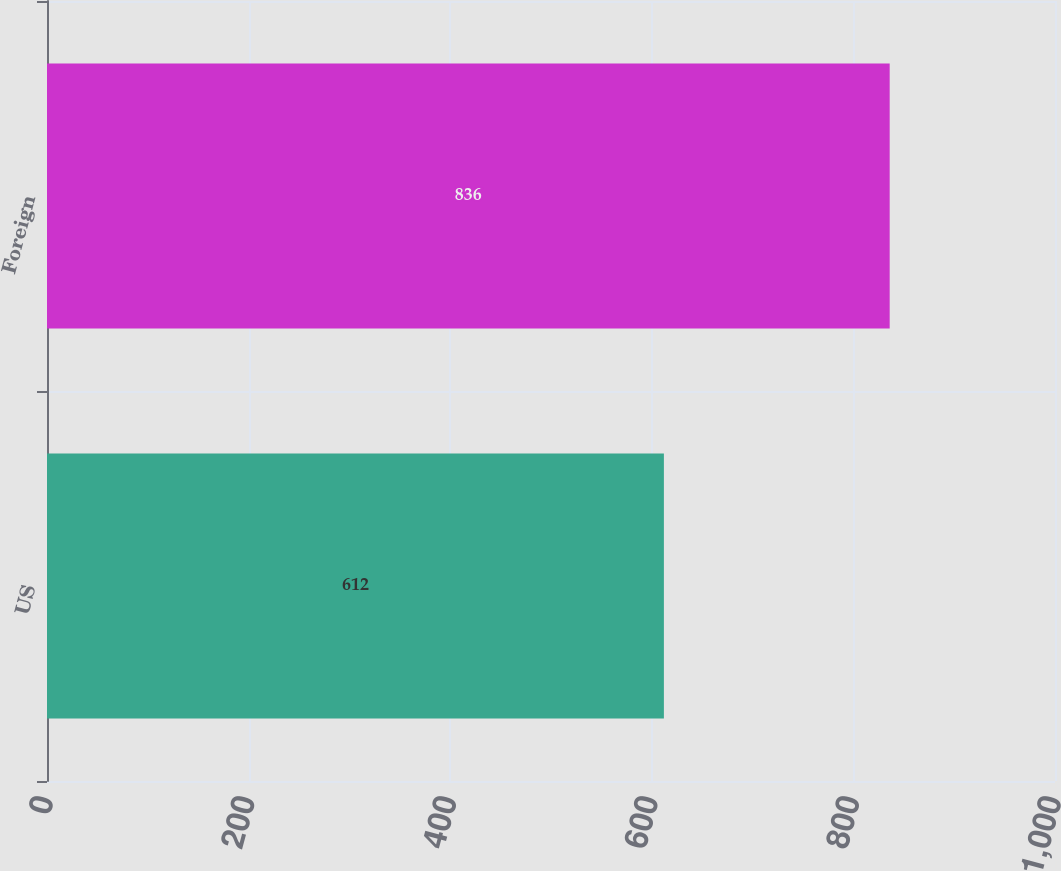Convert chart to OTSL. <chart><loc_0><loc_0><loc_500><loc_500><bar_chart><fcel>US<fcel>Foreign<nl><fcel>612<fcel>836<nl></chart> 